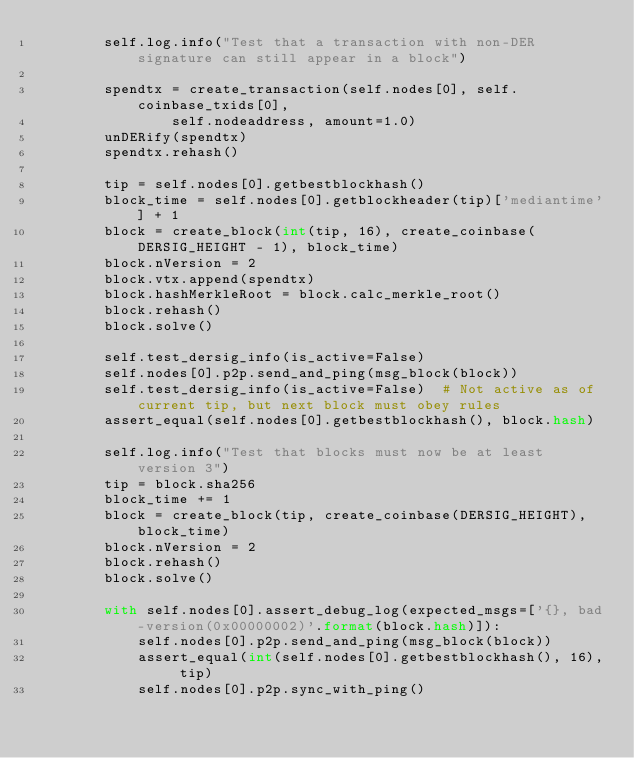Convert code to text. <code><loc_0><loc_0><loc_500><loc_500><_Python_>        self.log.info("Test that a transaction with non-DER signature can still appear in a block")

        spendtx = create_transaction(self.nodes[0], self.coinbase_txids[0],
                self.nodeaddress, amount=1.0)
        unDERify(spendtx)
        spendtx.rehash()

        tip = self.nodes[0].getbestblockhash()
        block_time = self.nodes[0].getblockheader(tip)['mediantime'] + 1
        block = create_block(int(tip, 16), create_coinbase(DERSIG_HEIGHT - 1), block_time)
        block.nVersion = 2
        block.vtx.append(spendtx)
        block.hashMerkleRoot = block.calc_merkle_root()
        block.rehash()
        block.solve()

        self.test_dersig_info(is_active=False)
        self.nodes[0].p2p.send_and_ping(msg_block(block))
        self.test_dersig_info(is_active=False)  # Not active as of current tip, but next block must obey rules
        assert_equal(self.nodes[0].getbestblockhash(), block.hash)

        self.log.info("Test that blocks must now be at least version 3")
        tip = block.sha256
        block_time += 1
        block = create_block(tip, create_coinbase(DERSIG_HEIGHT), block_time)
        block.nVersion = 2
        block.rehash()
        block.solve()

        with self.nodes[0].assert_debug_log(expected_msgs=['{}, bad-version(0x00000002)'.format(block.hash)]):
            self.nodes[0].p2p.send_and_ping(msg_block(block))
            assert_equal(int(self.nodes[0].getbestblockhash(), 16), tip)
            self.nodes[0].p2p.sync_with_ping()
</code> 